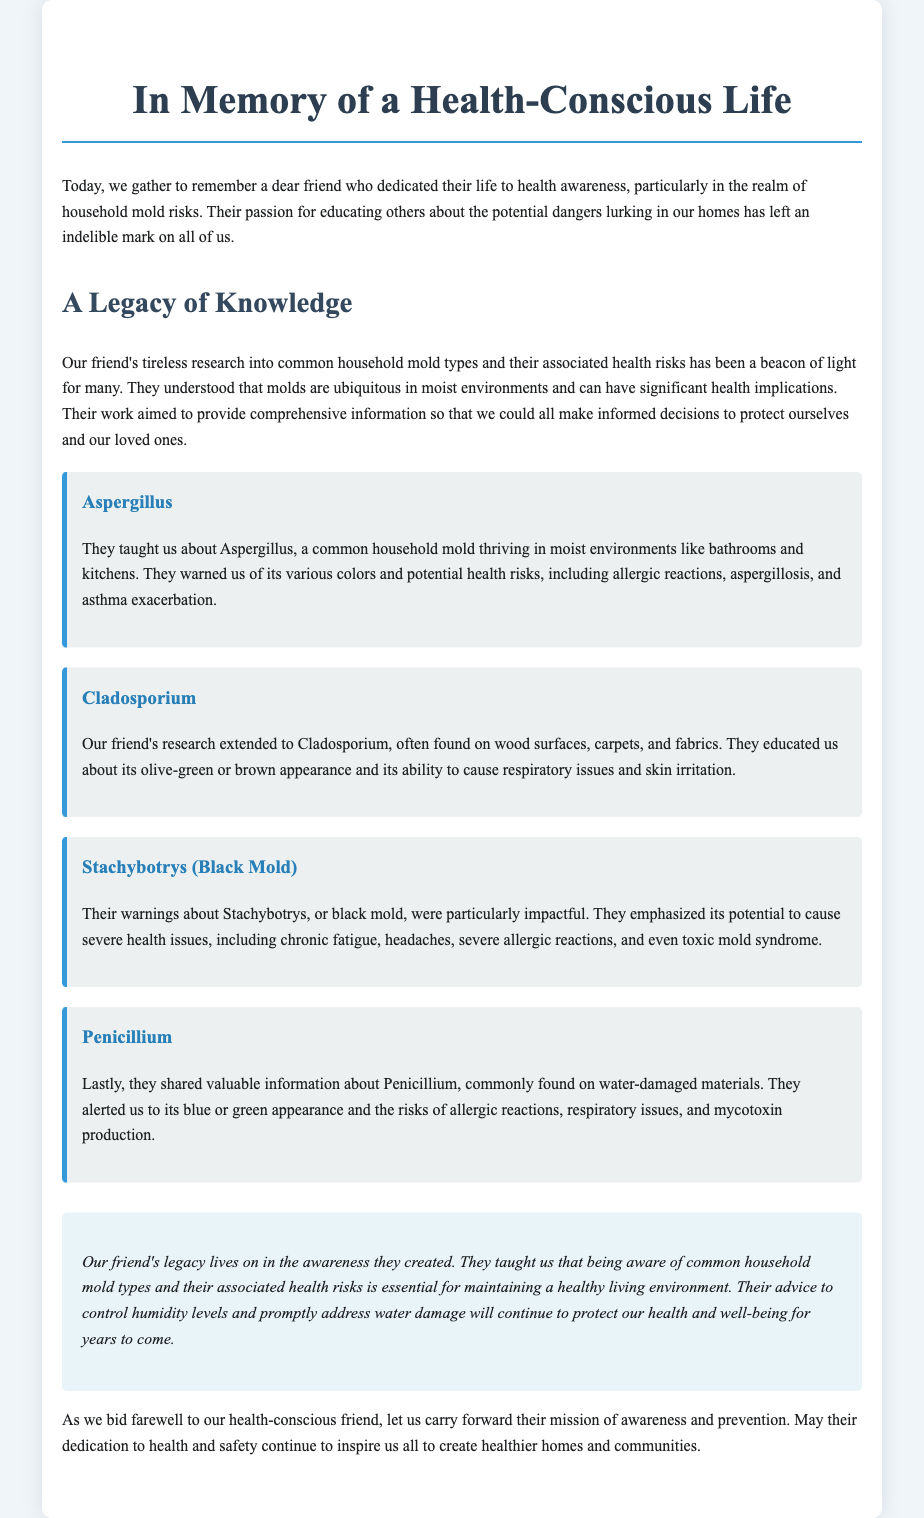What types of mold are discussed? The document specifically mentions Aspergillus, Cladosporium, Stachybotrys (Black Mold), and Penicillium as common household mold types.
Answer: Aspergillus, Cladosporium, Stachybotrys (Black Mold), Penicillium What are the health risks associated with Stachybotrys? The document states that Stachybotrys can cause severe health issues, including chronic fatigue, headaches, severe allergic reactions, and even toxic mold syndrome.
Answer: Chronic fatigue, headaches, severe allergic reactions, toxic mold syndrome What is the appearance of Cladosporium? The eulogy describes Cladosporium as having an olive-green or brown appearance.
Answer: Olive-green or brown What caution did our friend emphasize regarding humidity? The document highlights the importance of controlling humidity levels to prevent mold growth.
Answer: Control humidity levels How did our friend contribute to health awareness? The document states that our friend dedicated their life to health awareness, particularly regarding household mold risks.
Answer: Health awareness about household mold risks What was the primary setting our friend focused on for mold presence? The eulogy mentions that molds thrive in wet environments like bathrooms and kitchens.
Answer: Moist environments, bathrooms, kitchens Which mold type is commonly found on water-damaged materials? The document indicates that Penicillium is commonly found on water-damaged materials.
Answer: Penicillium What is the overall message about mold awareness? The conclusion emphasizes the necessity of being aware of common household mold types and their health risks.
Answer: Awareness of mold types and health risks 